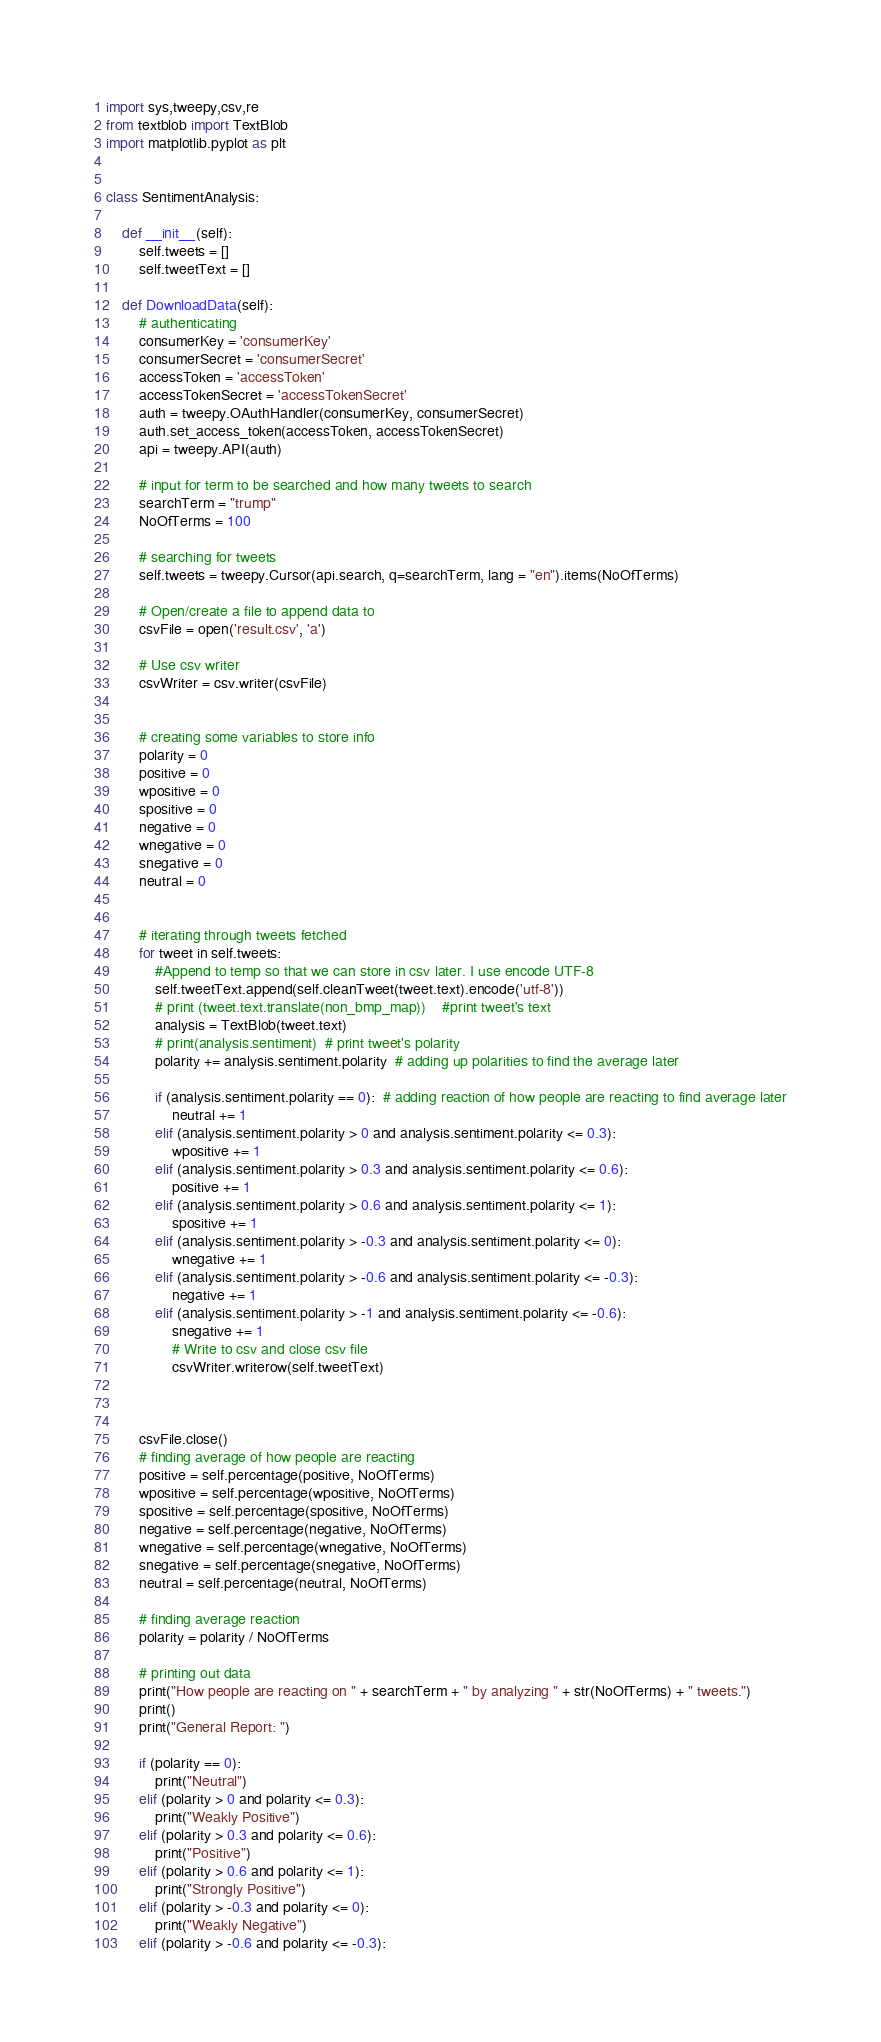Convert code to text. <code><loc_0><loc_0><loc_500><loc_500><_Python_>
import sys,tweepy,csv,re
from textblob import TextBlob
import matplotlib.pyplot as plt


class SentimentAnalysis:

    def __init__(self):
        self.tweets = []
        self.tweetText = []

    def DownloadData(self):
        # authenticating
        consumerKey = 'consumerKey'
        consumerSecret = 'consumerSecret'
        accessToken = 'accessToken'
        accessTokenSecret = 'accessTokenSecret'
        auth = tweepy.OAuthHandler(consumerKey, consumerSecret)
        auth.set_access_token(accessToken, accessTokenSecret)
        api = tweepy.API(auth)

        # input for term to be searched and how many tweets to search
        searchTerm = "trump"
        NoOfTerms = 100

        # searching for tweets
        self.tweets = tweepy.Cursor(api.search, q=searchTerm, lang = "en").items(NoOfTerms)

        # Open/create a file to append data to
        csvFile = open('result.csv', 'a')

        # Use csv writer
        csvWriter = csv.writer(csvFile)


        # creating some variables to store info
        polarity = 0
        positive = 0
        wpositive = 0
        spositive = 0
        negative = 0
        wnegative = 0
        snegative = 0
        neutral = 0


        # iterating through tweets fetched
        for tweet in self.tweets:
            #Append to temp so that we can store in csv later. I use encode UTF-8
            self.tweetText.append(self.cleanTweet(tweet.text).encode('utf-8'))
            # print (tweet.text.translate(non_bmp_map))    #print tweet's text
            analysis = TextBlob(tweet.text)
            # print(analysis.sentiment)  # print tweet's polarity
            polarity += analysis.sentiment.polarity  # adding up polarities to find the average later

            if (analysis.sentiment.polarity == 0):  # adding reaction of how people are reacting to find average later
                neutral += 1
            elif (analysis.sentiment.polarity > 0 and analysis.sentiment.polarity <= 0.3):
                wpositive += 1
            elif (analysis.sentiment.polarity > 0.3 and analysis.sentiment.polarity <= 0.6):
                positive += 1
            elif (analysis.sentiment.polarity > 0.6 and analysis.sentiment.polarity <= 1):
                spositive += 1
            elif (analysis.sentiment.polarity > -0.3 and analysis.sentiment.polarity <= 0):
                wnegative += 1
            elif (analysis.sentiment.polarity > -0.6 and analysis.sentiment.polarity <= -0.3):
                negative += 1
            elif (analysis.sentiment.polarity > -1 and analysis.sentiment.polarity <= -0.6):
                snegative += 1
                # Write to csv and close csv file
                csvWriter.writerow(self.tweetText)
                


        csvFile.close()
        # finding average of how people are reacting
        positive = self.percentage(positive, NoOfTerms)
        wpositive = self.percentage(wpositive, NoOfTerms)
        spositive = self.percentage(spositive, NoOfTerms)
        negative = self.percentage(negative, NoOfTerms)
        wnegative = self.percentage(wnegative, NoOfTerms)
        snegative = self.percentage(snegative, NoOfTerms)
        neutral = self.percentage(neutral, NoOfTerms)

        # finding average reaction
        polarity = polarity / NoOfTerms

        # printing out data
        print("How people are reacting on " + searchTerm + " by analyzing " + str(NoOfTerms) + " tweets.")
        print()
        print("General Report: ")

        if (polarity == 0):
            print("Neutral")
        elif (polarity > 0 and polarity <= 0.3):
            print("Weakly Positive")
        elif (polarity > 0.3 and polarity <= 0.6):
            print("Positive")
        elif (polarity > 0.6 and polarity <= 1):
            print("Strongly Positive")
        elif (polarity > -0.3 and polarity <= 0):
            print("Weakly Negative")
        elif (polarity > -0.6 and polarity <= -0.3):</code> 